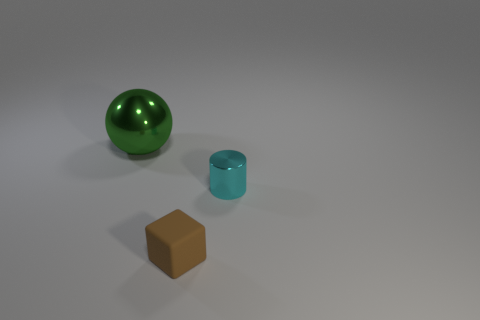Are there any big balls?
Make the answer very short. Yes. What color is the small cylinder that is the same material as the big sphere?
Ensure brevity in your answer.  Cyan. There is a shiny object that is on the right side of the shiny object that is on the left side of the object that is in front of the cyan object; what is its color?
Offer a terse response. Cyan. There is a cylinder; is it the same size as the metallic object that is on the left side of the cube?
Keep it short and to the point. No. How many things are metal objects in front of the large green thing or objects that are in front of the large green thing?
Your response must be concise. 2. What shape is the thing that is the same size as the brown rubber cube?
Your answer should be compact. Cylinder. The object that is to the left of the small thing in front of the shiny thing to the right of the matte cube is what shape?
Provide a succinct answer. Sphere. Is the number of tiny brown cubes that are behind the large green sphere the same as the number of brown rubber objects?
Give a very brief answer. No. Is the size of the green metal thing the same as the brown rubber object?
Keep it short and to the point. No. How many metallic objects are big red blocks or tiny cubes?
Ensure brevity in your answer.  0. 